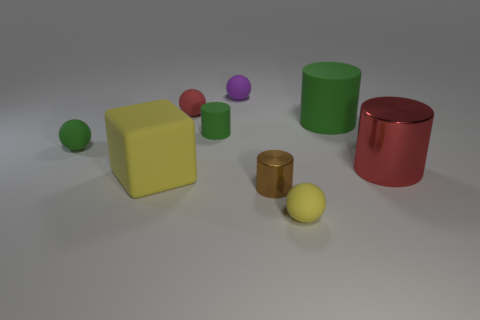Are there any green matte spheres to the left of the small sphere that is in front of the red thing that is in front of the small red thing? yes 